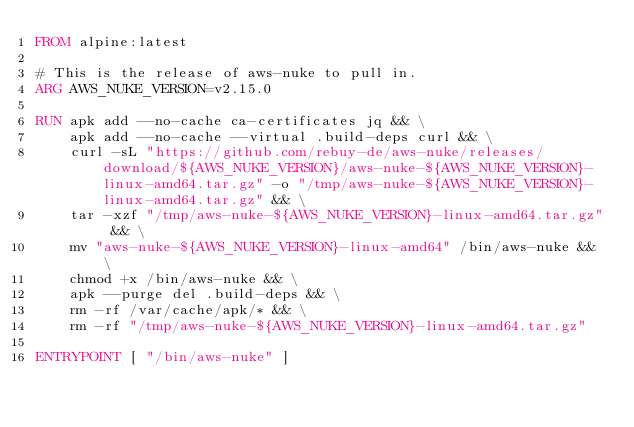Convert code to text. <code><loc_0><loc_0><loc_500><loc_500><_Dockerfile_>FROM alpine:latest

# This is the release of aws-nuke to pull in.
ARG AWS_NUKE_VERSION=v2.15.0

RUN apk add --no-cache ca-certificates jq && \
    apk add --no-cache --virtual .build-deps curl && \
    curl -sL "https://github.com/rebuy-de/aws-nuke/releases/download/${AWS_NUKE_VERSION}/aws-nuke-${AWS_NUKE_VERSION}-linux-amd64.tar.gz" -o "/tmp/aws-nuke-${AWS_NUKE_VERSION}-linux-amd64.tar.gz" && \
    tar -xzf "/tmp/aws-nuke-${AWS_NUKE_VERSION}-linux-amd64.tar.gz" && \
    mv "aws-nuke-${AWS_NUKE_VERSION}-linux-amd64" /bin/aws-nuke && \
    chmod +x /bin/aws-nuke && \
    apk --purge del .build-deps && \
    rm -rf /var/cache/apk/* && \
    rm -rf "/tmp/aws-nuke-${AWS_NUKE_VERSION}-linux-amd64.tar.gz"

ENTRYPOINT [ "/bin/aws-nuke" ]
</code> 